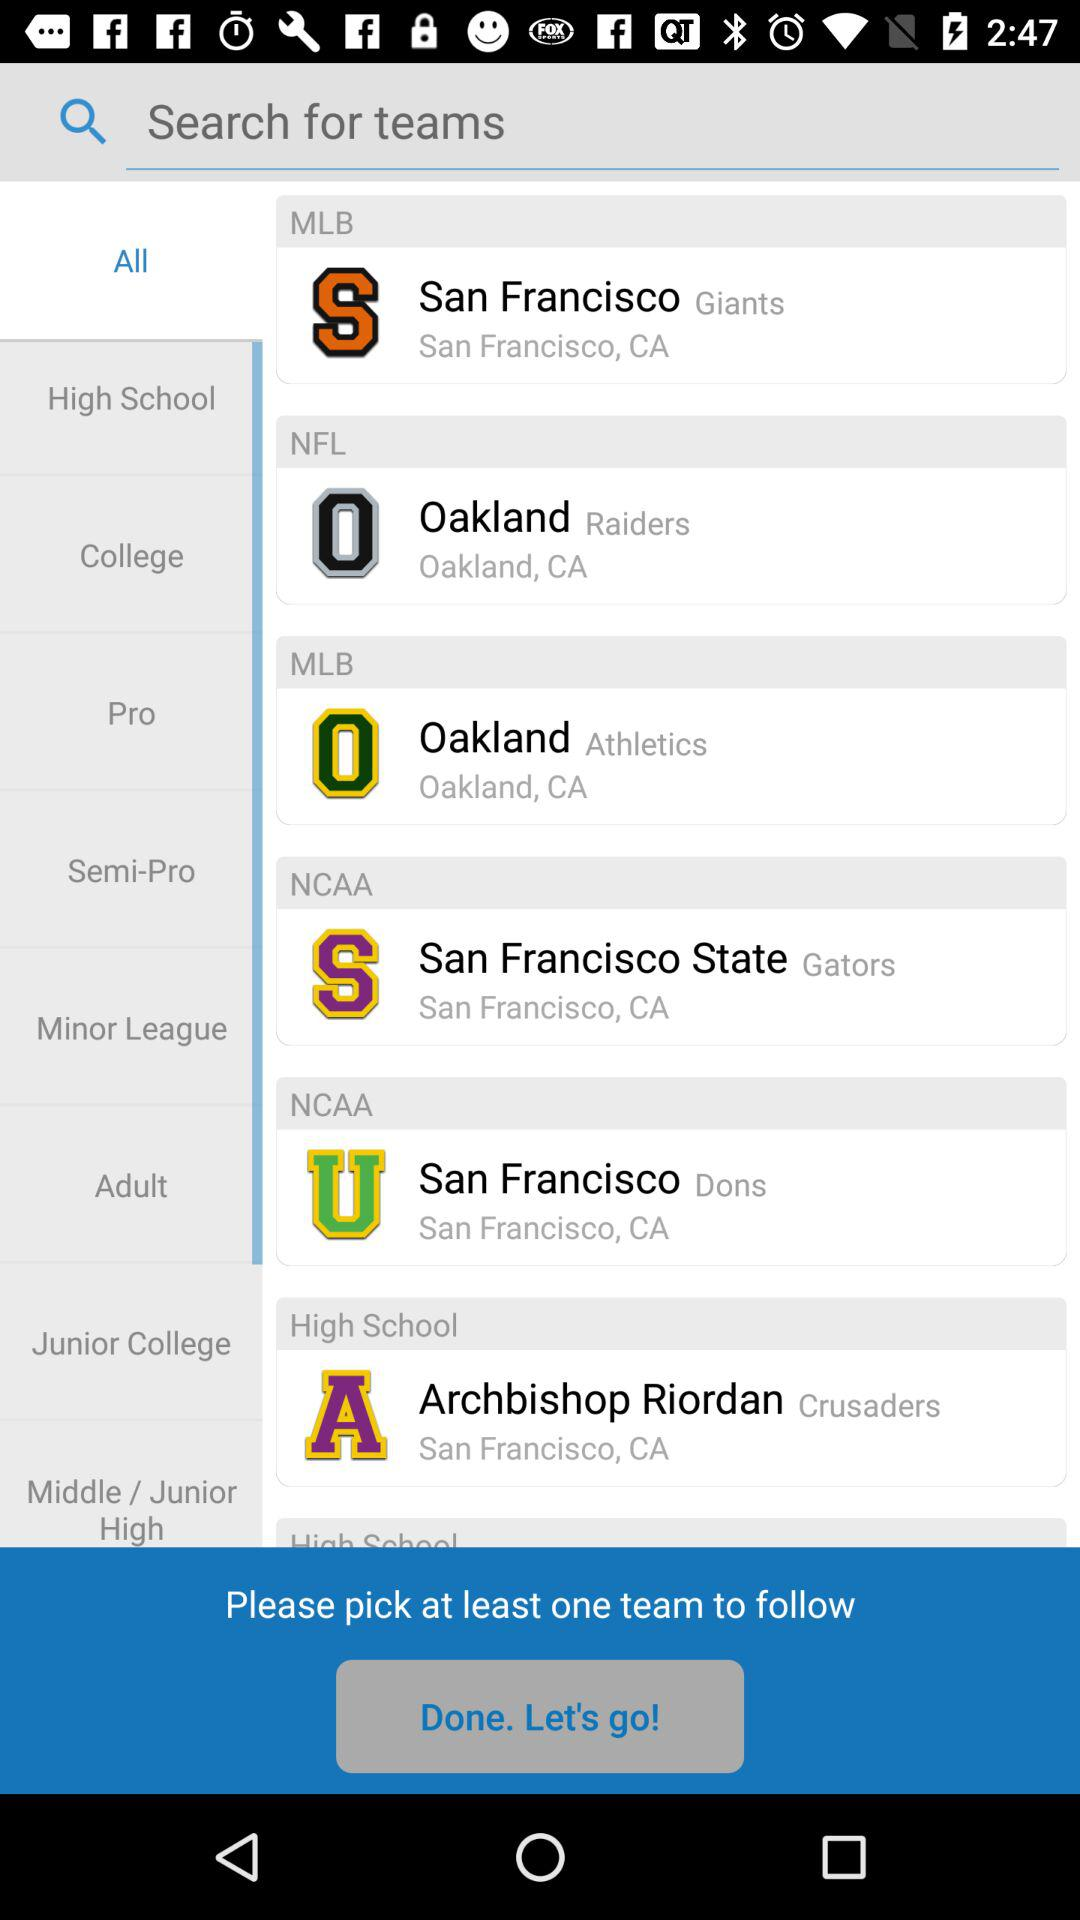How many teams can be picked to follow? You can pick atleast one team to follow. 